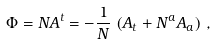<formula> <loc_0><loc_0><loc_500><loc_500>\Phi = N A ^ { t } = - \frac { 1 } { N } \, \left ( A _ { t } + N ^ { a } A _ { a } \right ) \, ,</formula> 